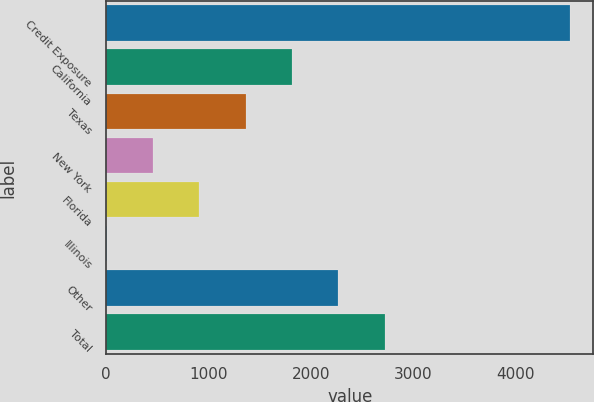<chart> <loc_0><loc_0><loc_500><loc_500><bar_chart><fcel>Credit Exposure<fcel>California<fcel>Texas<fcel>New York<fcel>Florida<fcel>Illinois<fcel>Other<fcel>Total<nl><fcel>4536<fcel>1816.8<fcel>1363.6<fcel>457.2<fcel>910.4<fcel>4<fcel>2270<fcel>2723.2<nl></chart> 